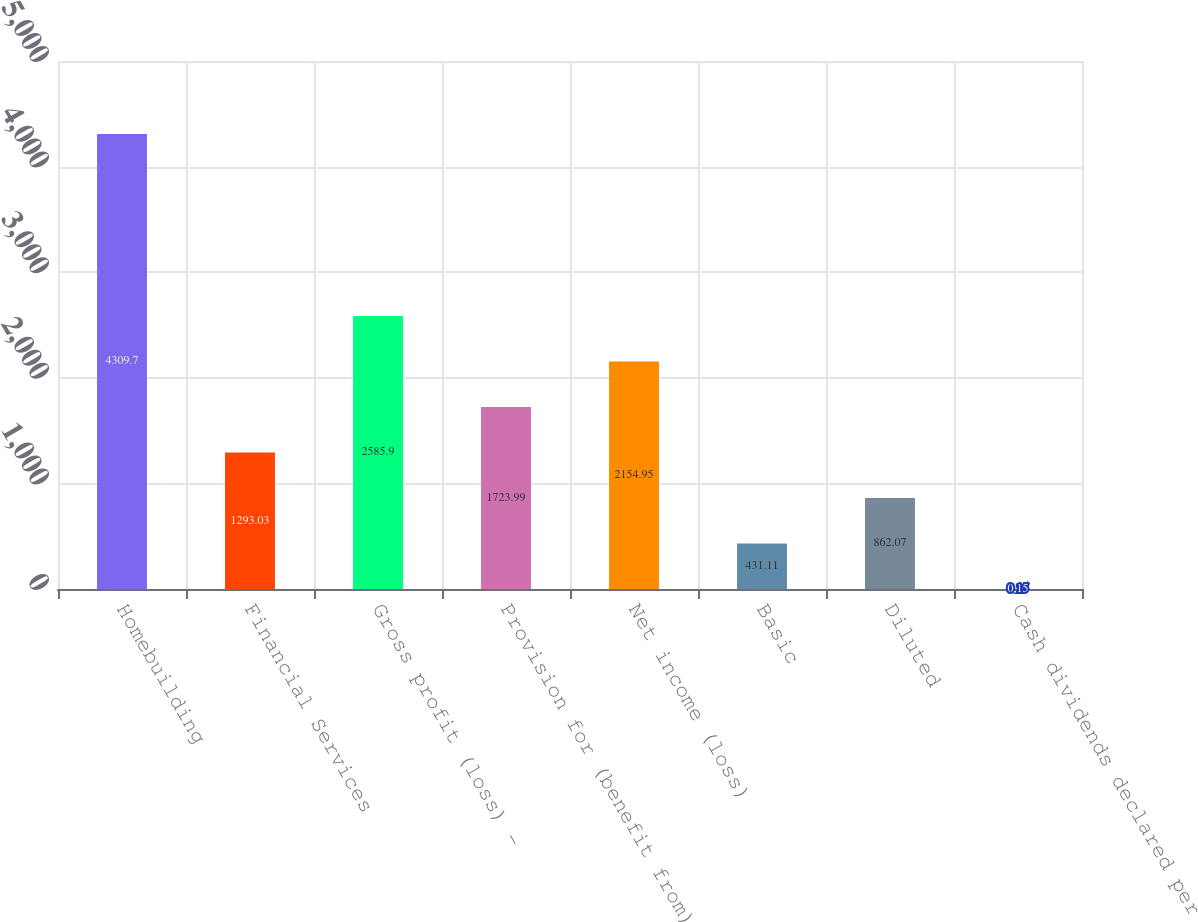Convert chart to OTSL. <chart><loc_0><loc_0><loc_500><loc_500><bar_chart><fcel>Homebuilding<fcel>Financial Services<fcel>Gross profit (loss) -<fcel>Provision for (benefit from)<fcel>Net income (loss)<fcel>Basic<fcel>Diluted<fcel>Cash dividends declared per<nl><fcel>4309.7<fcel>1293.03<fcel>2585.9<fcel>1723.99<fcel>2154.95<fcel>431.11<fcel>862.07<fcel>0.15<nl></chart> 